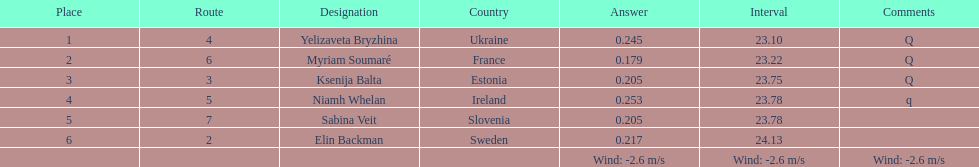Who holds the top rank among players? Yelizaveta Bryzhina. 